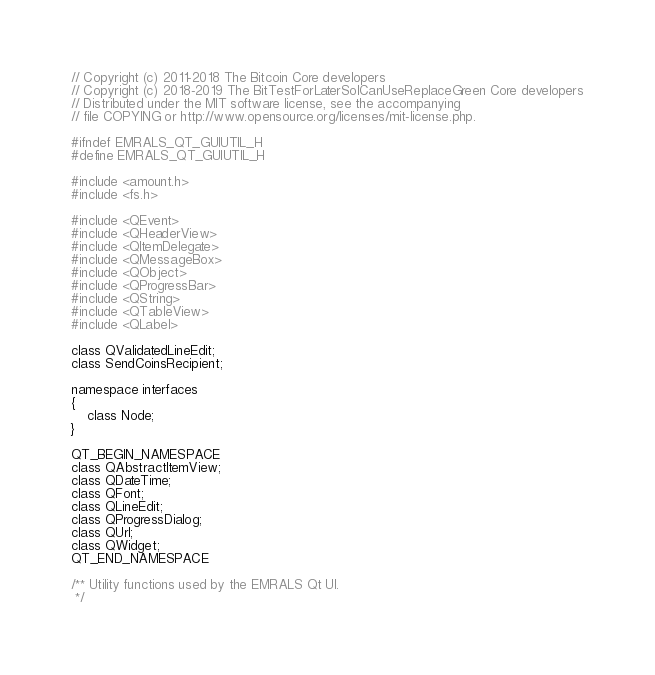Convert code to text. <code><loc_0><loc_0><loc_500><loc_500><_C_>// Copyright (c) 2011-2018 The Bitcoin Core developers
// Copyright (c) 2018-2019 The BitTestForLaterSoICanUseReplaceGreen Core developers
// Distributed under the MIT software license, see the accompanying
// file COPYING or http://www.opensource.org/licenses/mit-license.php.

#ifndef EMRALS_QT_GUIUTIL_H
#define EMRALS_QT_GUIUTIL_H

#include <amount.h>
#include <fs.h>

#include <QEvent>
#include <QHeaderView>
#include <QItemDelegate>
#include <QMessageBox>
#include <QObject>
#include <QProgressBar>
#include <QString>
#include <QTableView>
#include <QLabel>

class QValidatedLineEdit;
class SendCoinsRecipient;

namespace interfaces
{
    class Node;
}

QT_BEGIN_NAMESPACE
class QAbstractItemView;
class QDateTime;
class QFont;
class QLineEdit;
class QProgressDialog;
class QUrl;
class QWidget;
QT_END_NAMESPACE

/** Utility functions used by the EMRALS Qt UI.
 */</code> 